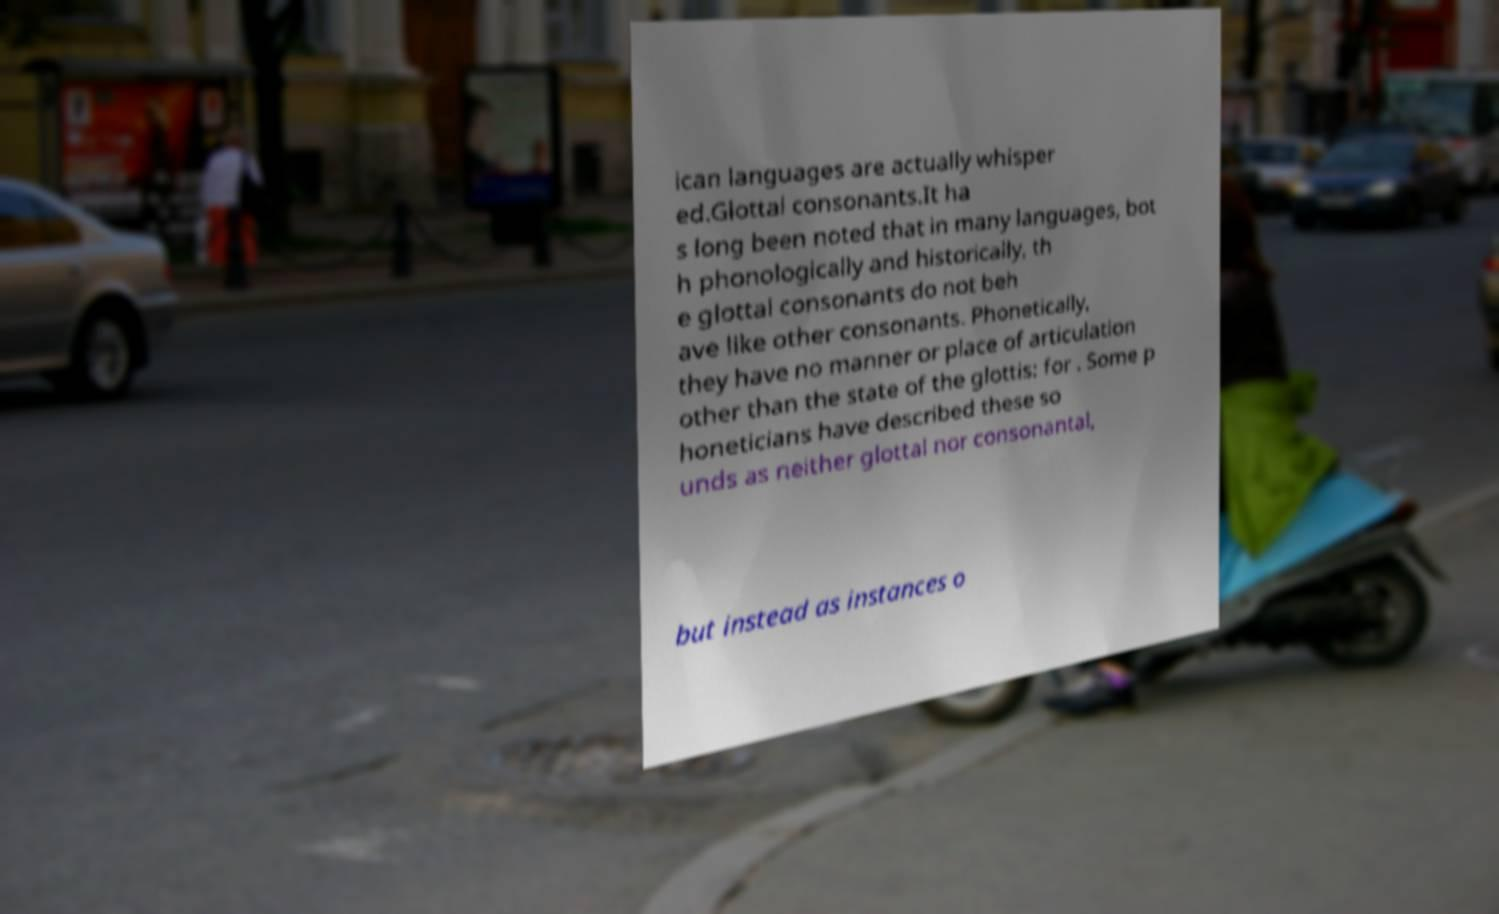Can you accurately transcribe the text from the provided image for me? ican languages are actually whisper ed.Glottal consonants.It ha s long been noted that in many languages, bot h phonologically and historically, th e glottal consonants do not beh ave like other consonants. Phonetically, they have no manner or place of articulation other than the state of the glottis: for . Some p honeticians have described these so unds as neither glottal nor consonantal, but instead as instances o 